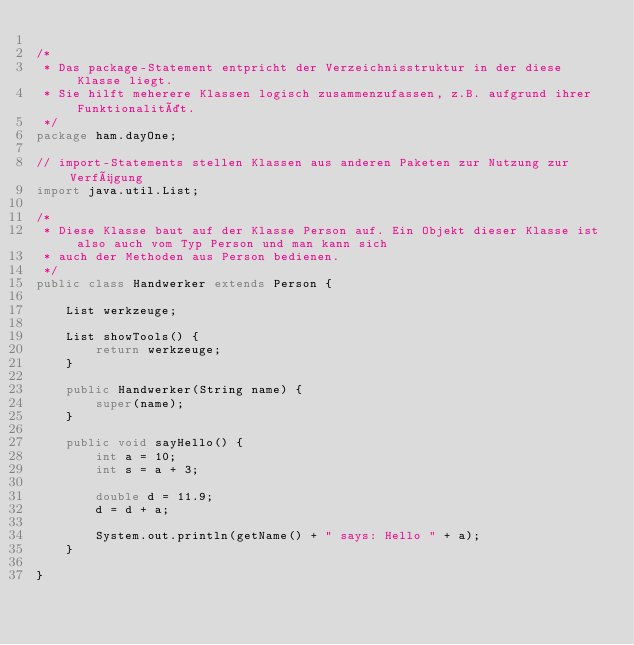Convert code to text. <code><loc_0><loc_0><loc_500><loc_500><_Java_>
/*
 * Das package-Statement entpricht der Verzeichnisstruktur in der diese Klasse liegt.
 * Sie hilft meherere Klassen logisch zusammenzufassen, z.B. aufgrund ihrer Funktionalität.
 */
package ham.dayOne;

// import-Statements stellen Klassen aus anderen Paketen zur Nutzung zur Verfügung
import java.util.List;

/*
 * Diese Klasse baut auf der Klasse Person auf. Ein Objekt dieser Klasse ist also auch vom Typ Person und man kann sich
 * auch der Methoden aus Person bedienen.
 */
public class Handwerker extends Person {

    List werkzeuge;

    List showTools() {
        return werkzeuge;
    }

    public Handwerker(String name) {
        super(name);
    }

    public void sayHello() {
        int a = 10;
        int s = a + 3;

        double d = 11.9;
        d = d + a;

        System.out.println(getName() + " says: Hello " + a);
    }

}
</code> 